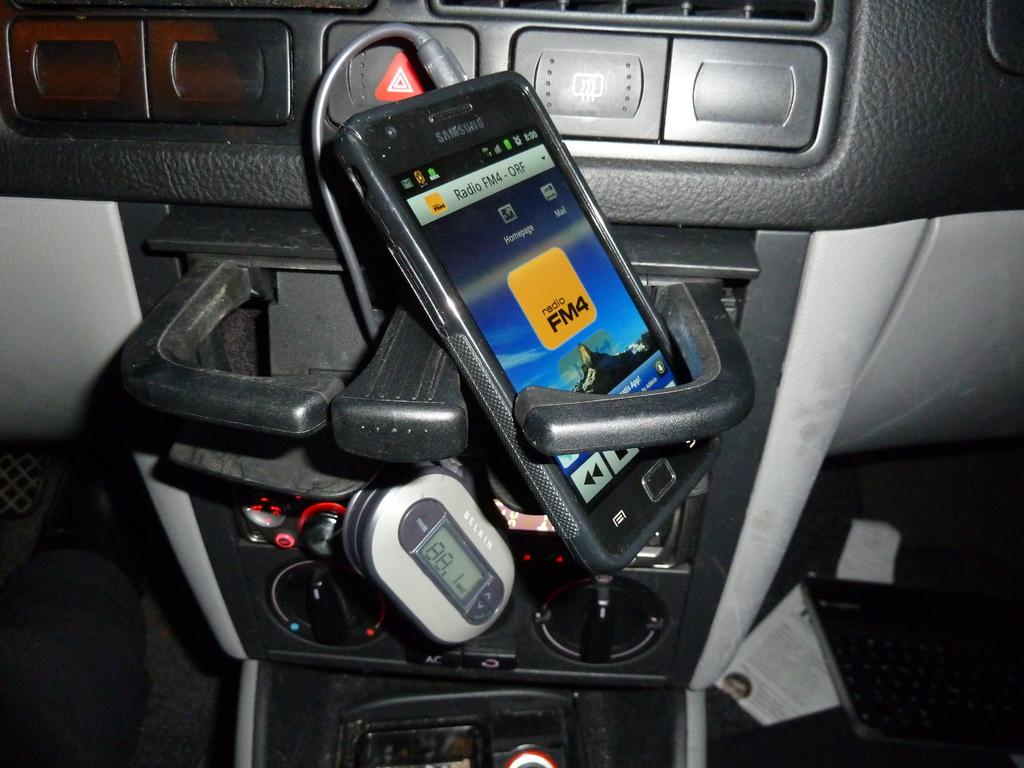What type of setting is depicted in the image? The image shows an inside view of a vehicle. What electronic device can be seen inside the vehicle? There is a phone visible inside the vehicle. What is used for listening to audio inside the vehicle? Earphones are present inside the vehicle. What type of paper is visible inside the vehicle? There is a paper visible inside the vehicle. What other device can be seen inside the vehicle? A device is visible inside the vehicle. Can you see a giraffe teaching the device in the image? There is no giraffe or teaching activity present in the image; it shows an inside view of a vehicle with various items visible. 